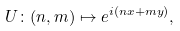Convert formula to latex. <formula><loc_0><loc_0><loc_500><loc_500>U \colon ( n , m ) \mapsto e ^ { i ( n x + m y ) } ,</formula> 